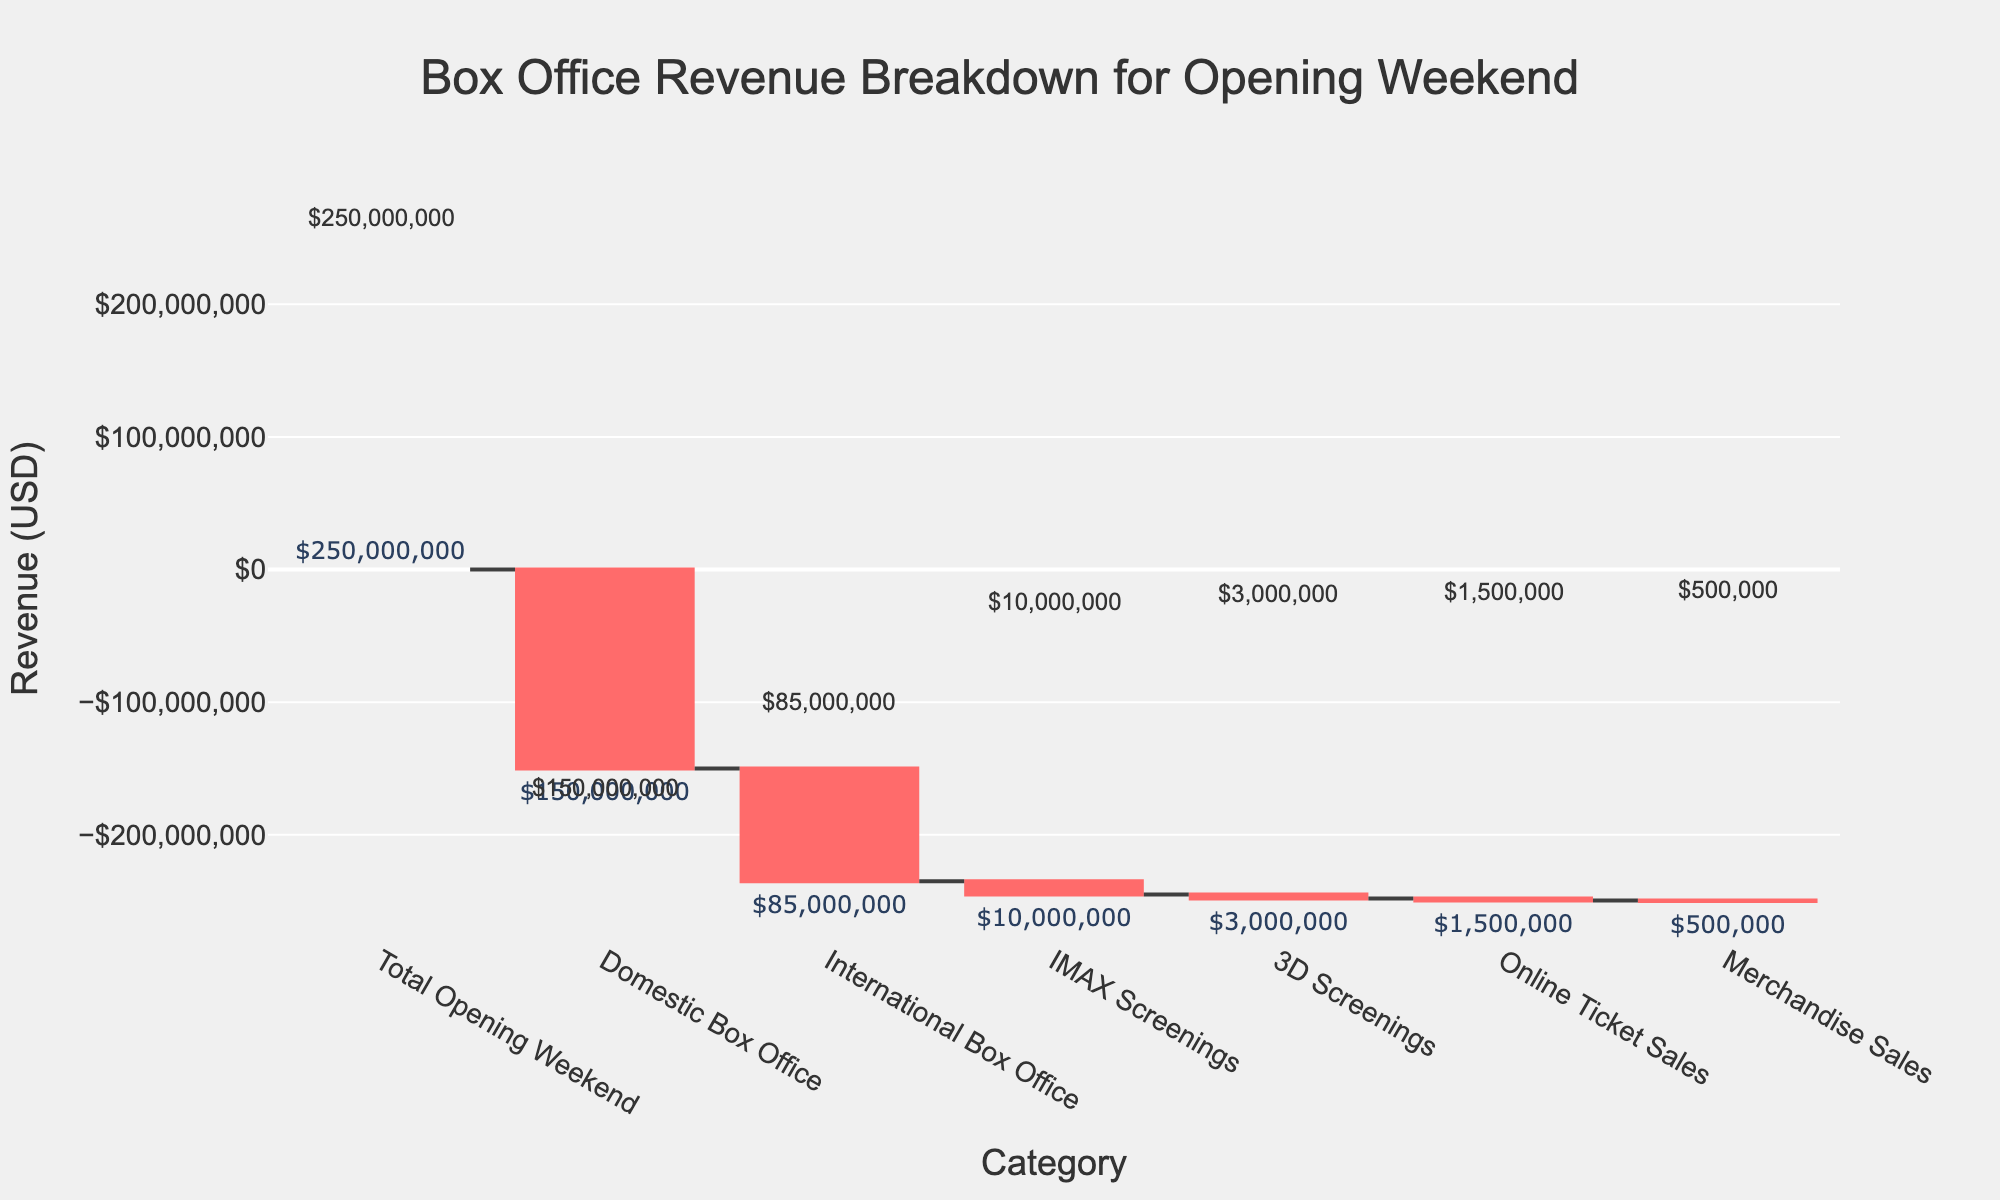Which category is responsible for the largest negative impact on the total revenue? The figure shows that the "Domestic Box Office" has the largest segment in red, indicating a negative value.
Answer: Domestic Box Office What is the total revenue generated from International Box Office and IMAX Screenings combined? The values for International Box Office and IMAX Screenings are -$85,000,000 and -$10,000,000 respectively. Adding them gives -$85,000,000 + -$10,000,000 = -$95,000,000.
Answer: -$95,000,000 How much revenue was lost from Online Ticket Sales? The figure labels Online Ticket Sales with a value of -$1,500,000.
Answer: $1,500,000 Which revenue category had the smallest negative impact? By comparing the sizes of the negative bars in the figure, Merchandise Sales has the smallest value.
Answer: Merchandise Sales What is the difference between the revenues from 3D Screenings and Domestic Box Office? The values are -$3,000,000 for 3D Screenings and -$150,000,000 for Domestic Box Office. The difference is -$150,000,000 -(-$3,000,000) = -$147,000,000.
Answer: $147,000,000 How much is the total revenue from Online Ticket Sales, Merchandise Sales, and 3D Screenings combined? The individual values for Online Ticket Sales, Merchandise Sales, and 3D Screenings are -$1,500,000, -$500,000, and -$3,000,000 respectively. Adding them gives -$1,500,000 + -$500,000 + -$3,000,000 = -$5,000,000.
Answer: $5,000,000 What is the net revenue after deducting all the observed categories from the Total Opening Weekend revenue? The Total Opening Weekend revenue is $250,000,000. Deduct all negative values: -$150,000,000 (Domestic Box Office), -$85,000,000 (International Box Office), -$10,000,000 (IMAX Screenings), -$3,000,000 (3D Screenings), -$1,500,000 (Online Ticket Sales), -$500,000 (Merchandise Sales). Sum of these negative values: -$250,000,000. Therefore, $250,000,000 - $250,000,000 = $0.
Answer: $0 Which revenue category between International Box Office and IMAX Screenings had more impact relative to its values? Comparing the lengths of the bars, the International Box Office value (-$85,000,000) has a greater negative impact than the IMAX Screenings (-$10,000,000).
Answer: International Box Office What is the approximate total value depicted if we only consider all revenue loss categories? Sum the negative values: -$150,000,000 (Domestic Box Office) -$85,000,000 (International Box Office), -$10,000,000 (IMAX Screenings), -$3,000,000 (3D Screenings), -$1,500,000 (Online Ticket Sales), -$500,000 (Merchandise Sales). Total is: -$150,000,000 + -$85,000,000 + -$10,000,000 + -$3,000,000 + -$1,500,000 + -$500,000 = -$250,000,000.
Answer: $250,000,000 